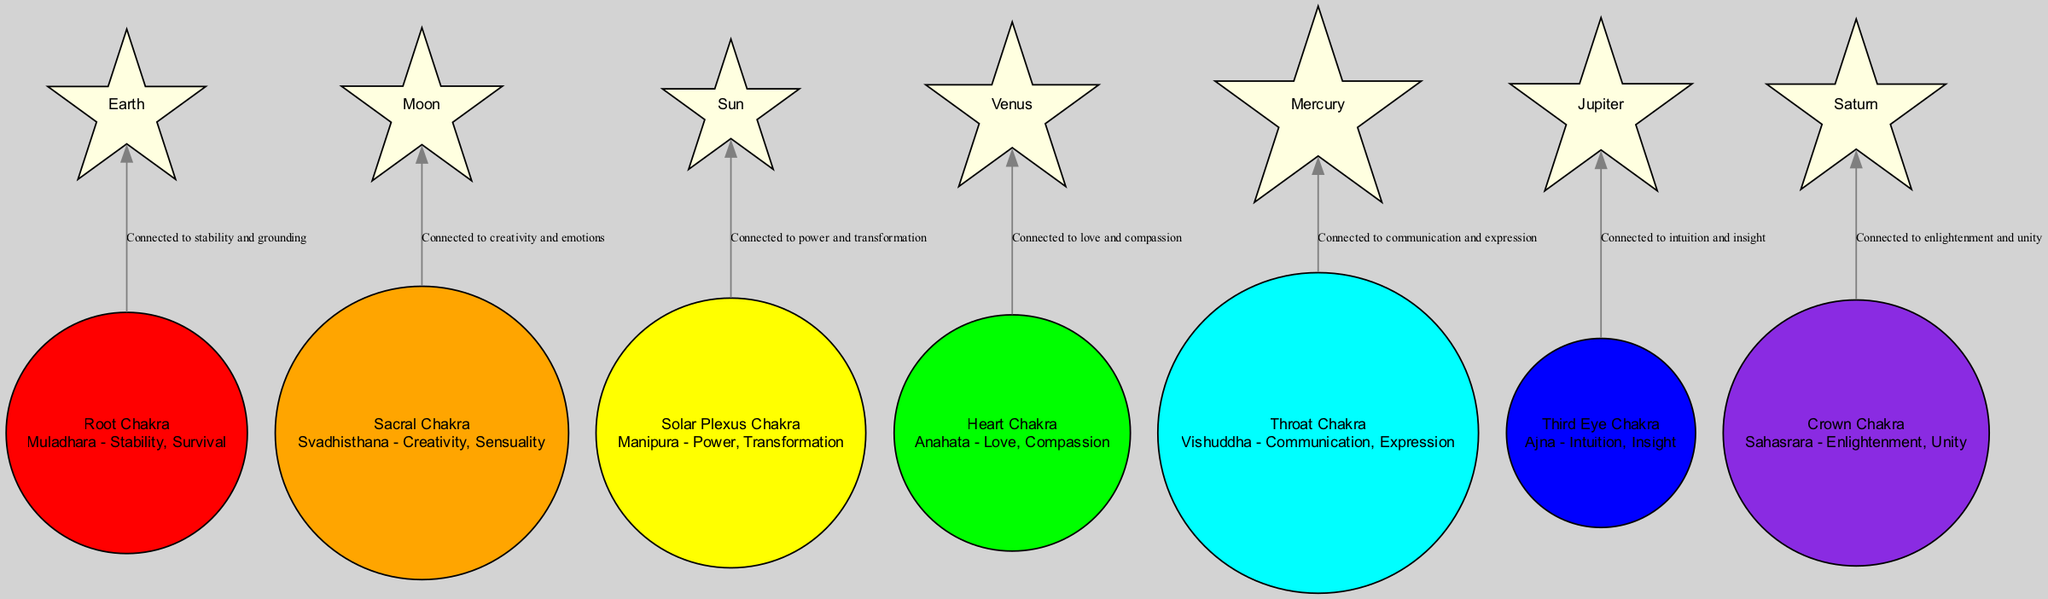What is the celestial body associated with the Heart Chakra? The Heart Chakra is linked with Venus, as indicated in the diagram where it shows the relationship between the chakra and the celestial body.
Answer: Venus How many chakras are represented in the diagram? The diagram includes seven chakra nodes, as specified in the list of nodes.
Answer: Seven What feeling is associated with the Third Eye Chakra? The description of the Third Eye Chakra specifies that it is linked to intuition and insight, which directly answers the question based on the information provided.
Answer: Intuition Which chakra is connected to the Earth? The root chakra is mapped to Earth in the diagram, represented as the node with that specific celestial connection.
Answer: Root Chakra What is the relationship between the Solar Plexus Chakra and the Sun? The diagram asserts that the Solar Plexus Chakra is connected to power and transformation through its link with the Sun.
Answer: Connected to power and transformation Which chakra corresponds to the Moon? The diagram directly associates the Sacral Chakra with the Moon, which is clearly labeled in the visual representation.
Answer: Sacral Chakra What color represents the Throat Chakra in the diagram? The Throat Chakra is colored cyan in the diagram, which is the designated color for that particular chakra.
Answer: Cyan Which celestial body represents enlightenment and unity? The diagram connects Saturn with the Crown Chakra, indicating that it symbolizes enlightenment and unity according to the relationship shown.
Answer: Saturn What aspect does the Heart Chakra promote? The description under the Heart Chakra indicates that it promotes love and compassion, specifying its emotional aspect related to the chakra.
Answer: Love and compassion 